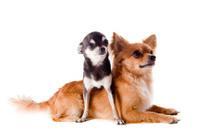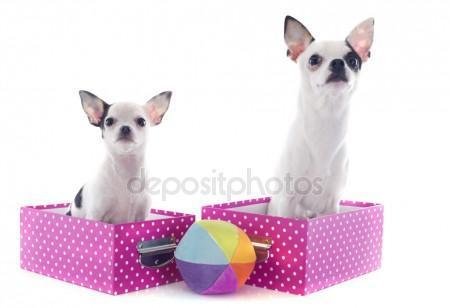The first image is the image on the left, the second image is the image on the right. Assess this claim about the two images: "One image shows exactly two dogs with each dog in its own separate container or placemat; no two dogs share a spot.". Correct or not? Answer yes or no. Yes. The first image is the image on the left, the second image is the image on the right. Evaluate the accuracy of this statement regarding the images: "An image includes two dogs, both in some type of container that features a polka-dotted pinkish element.". Is it true? Answer yes or no. Yes. 